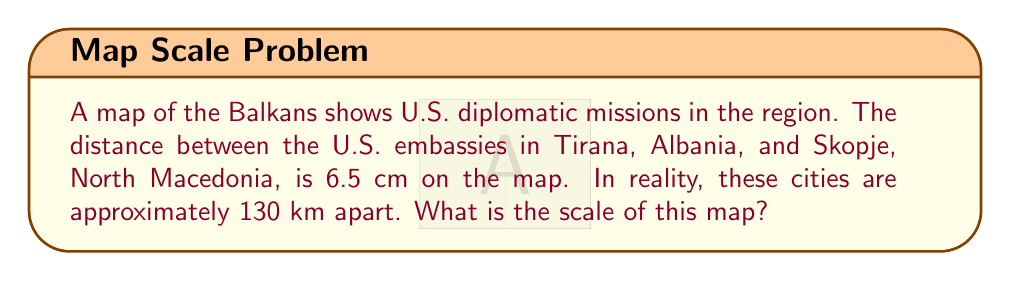Provide a solution to this math problem. To find the scale of the map, we need to compare the distance on the map to the actual distance. Let's approach this step-by-step:

1. Map distance: 6.5 cm
2. Actual distance: 130 km = 13,000,000 cm (converting km to cm)

3. The scale is represented as a ratio of map distance to actual distance:
   $$ \text{Scale} = \frac{\text{Map Distance}}{\text{Actual Distance}} $$

4. Substituting our values:
   $$ \text{Scale} = \frac{6.5 \text{ cm}}{13,000,000 \text{ cm}} $$

5. Simplify the fraction:
   $$ \text{Scale} = \frac{1}{2,000,000} $$

6. This can be expressed as 1:2,000,000, which means 1 cm on the map represents 2,000,000 cm (or 20 km) in reality.
Answer: 1:2,000,000 